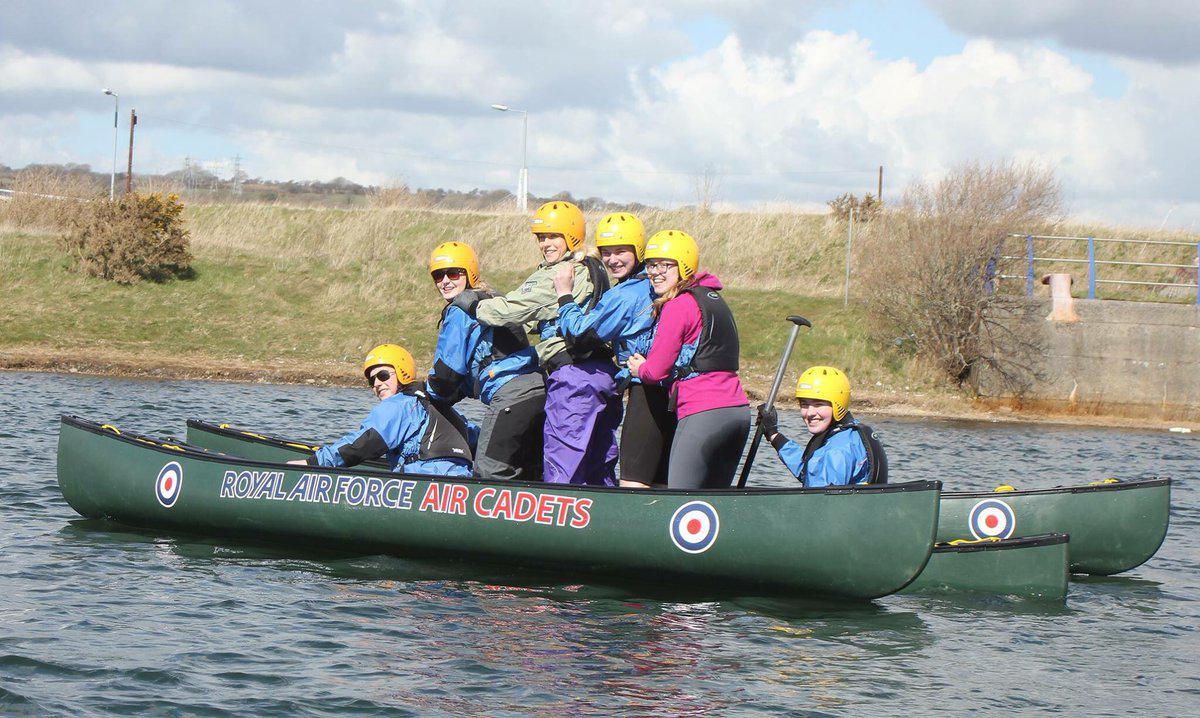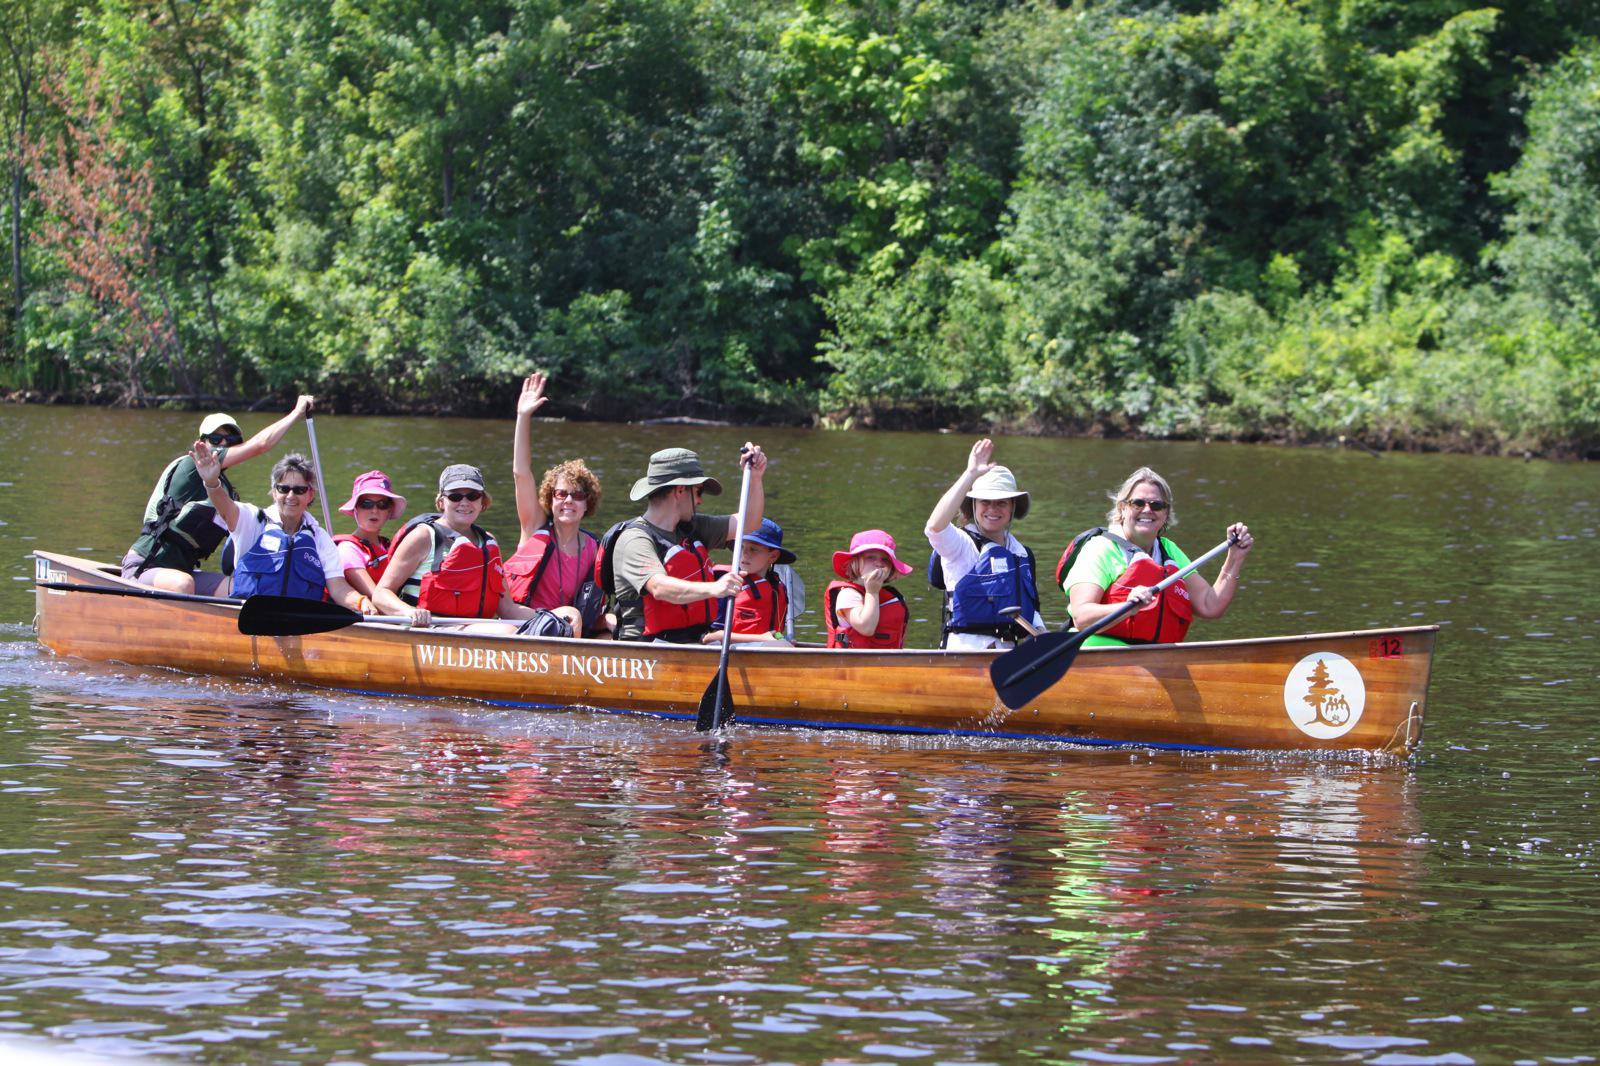The first image is the image on the left, the second image is the image on the right. Evaluate the accuracy of this statement regarding the images: "In one image, exactly two people, a man and a woman, are rowing a green canoe.". Is it true? Answer yes or no. No. The first image is the image on the left, the second image is the image on the right. Evaluate the accuracy of this statement regarding the images: "An image shows one dark green canoe with two riders.". Is it true? Answer yes or no. No. 